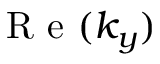<formula> <loc_0><loc_0><loc_500><loc_500>R e ( k _ { y } )</formula> 